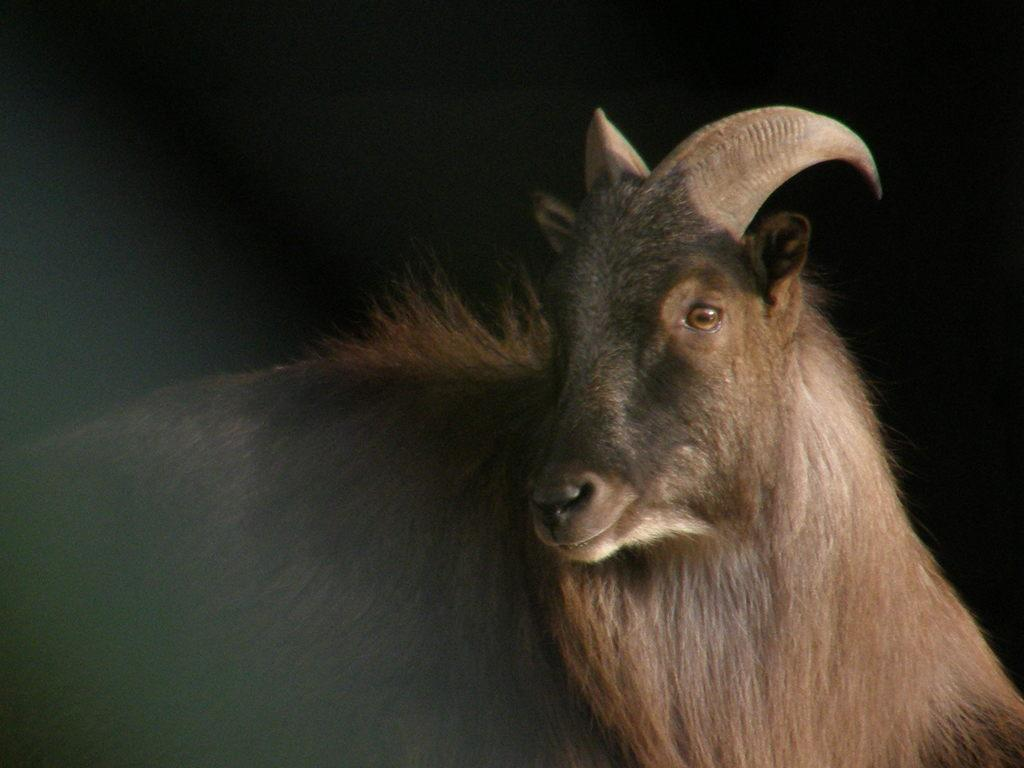What type of animal is in the image? The specific type of animal cannot be determined from the provided facts. Can you describe the background of the image? The background of the image is dark. What type of insurance policy does the animal have in the image? There is no information about insurance policies in the image, as it only features an animal and a dark background. 